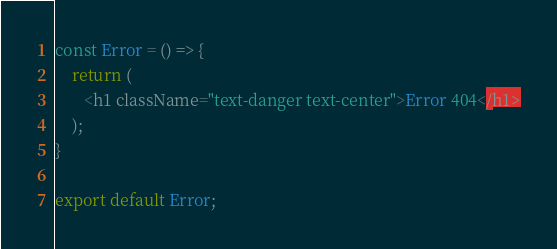Convert code to text. <code><loc_0><loc_0><loc_500><loc_500><_JavaScript_>const Error = () => {
    return (
       <h1 className="text-danger text-center">Error 404</h1>
    );
}

export default Error;</code> 